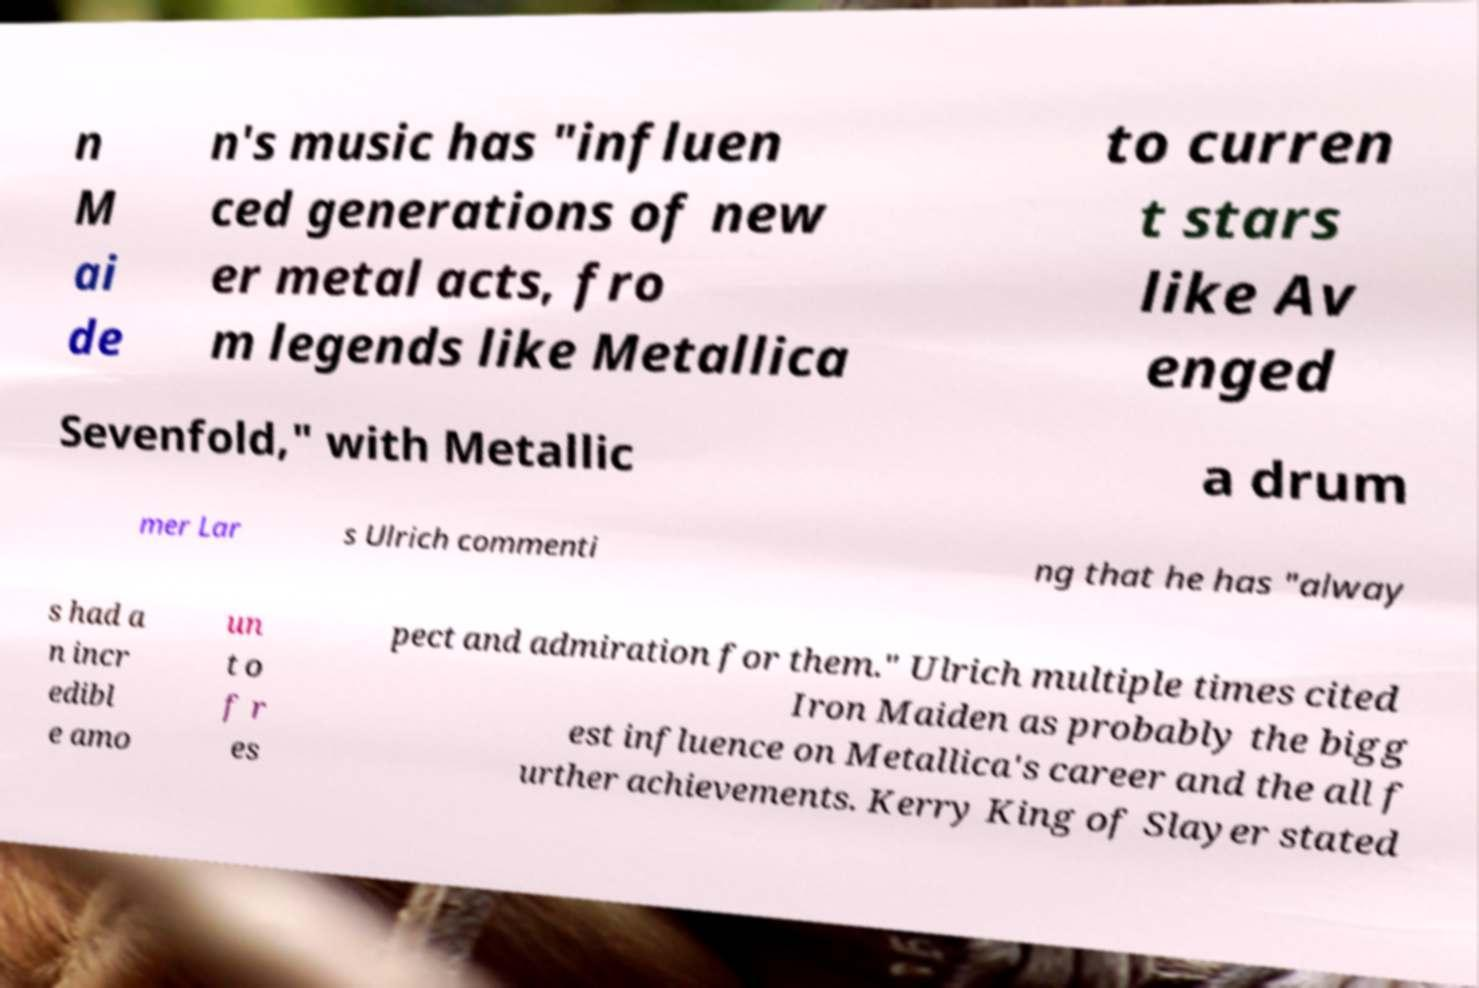For documentation purposes, I need the text within this image transcribed. Could you provide that? n M ai de n's music has "influen ced generations of new er metal acts, fro m legends like Metallica to curren t stars like Av enged Sevenfold," with Metallic a drum mer Lar s Ulrich commenti ng that he has "alway s had a n incr edibl e amo un t o f r es pect and admiration for them." Ulrich multiple times cited Iron Maiden as probably the bigg est influence on Metallica's career and the all f urther achievements. Kerry King of Slayer stated 